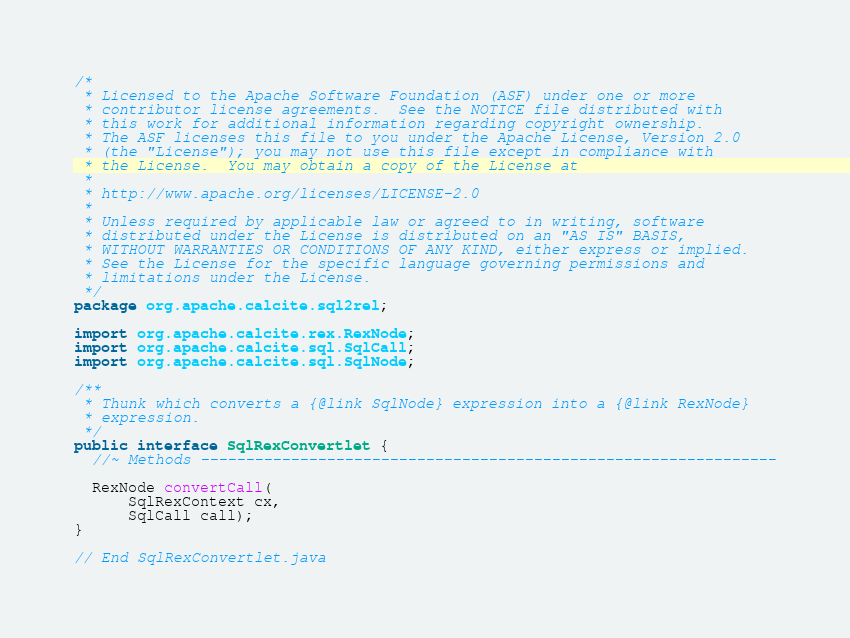<code> <loc_0><loc_0><loc_500><loc_500><_Java_>/*
 * Licensed to the Apache Software Foundation (ASF) under one or more
 * contributor license agreements.  See the NOTICE file distributed with
 * this work for additional information regarding copyright ownership.
 * The ASF licenses this file to you under the Apache License, Version 2.0
 * (the "License"); you may not use this file except in compliance with
 * the License.  You may obtain a copy of the License at
 *
 * http://www.apache.org/licenses/LICENSE-2.0
 *
 * Unless required by applicable law or agreed to in writing, software
 * distributed under the License is distributed on an "AS IS" BASIS,
 * WITHOUT WARRANTIES OR CONDITIONS OF ANY KIND, either express or implied.
 * See the License for the specific language governing permissions and
 * limitations under the License.
 */
package org.apache.calcite.sql2rel;

import org.apache.calcite.rex.RexNode;
import org.apache.calcite.sql.SqlCall;
import org.apache.calcite.sql.SqlNode;

/**
 * Thunk which converts a {@link SqlNode} expression into a {@link RexNode}
 * expression.
 */
public interface SqlRexConvertlet {
  //~ Methods ----------------------------------------------------------------

  RexNode convertCall(
      SqlRexContext cx,
      SqlCall call);
}

// End SqlRexConvertlet.java
</code> 